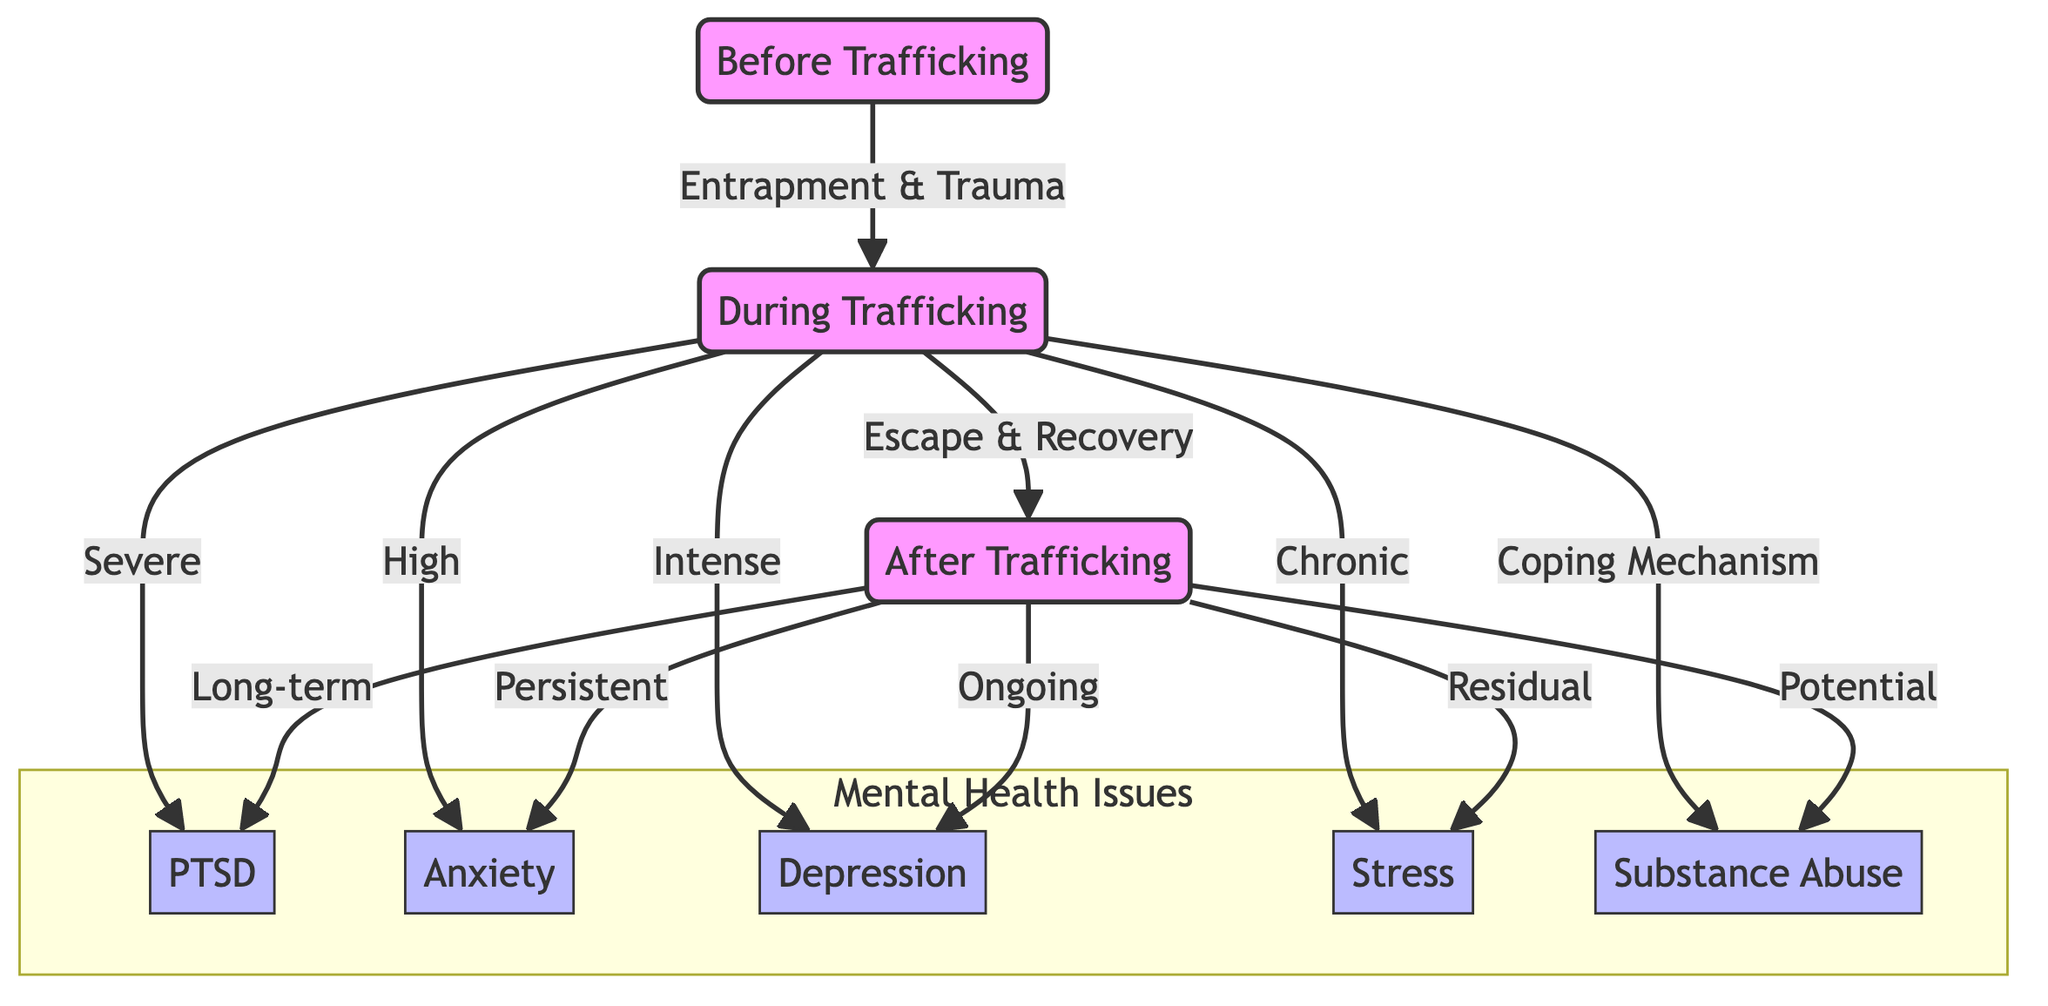What are the mental health issues identified during trafficking? The diagram highlights five mental health issues that individuals may experience during trafficking: PTSD, anxiety, depression, stress, and substance abuse. Each of these issues is connected to "During Trafficking."
Answer: PTSD, anxiety, depression, stress, substance abuse How many phases are identified in the diagram? The diagram outlines three distinct phases: Before Trafficking, During Trafficking, and After Trafficking. Each phase is represented in the diagram and marks a clear transition in the flow of mental health issues.
Answer: 3 What is the relationship between "During Trafficking" and "PTSD"? The relationship is that PTSD is linked to the "During Trafficking" phase, indicated by the arrow connecting these two nodes, where during trafficking individuals experience severe PTSD.
Answer: Severe What can be inferred about anxiety after trafficking? After trafficking, anxiety is described as "Persistent," indicating that anxiety can remain a significant issue for individuals even after escaping trafficking situations. This inference comes directly from the connection from the "After Trafficking" node to anxiety.
Answer: Persistent How many mental health issues are linked to "After Trafficking"? Four mental health issues are linked to "After Trafficking," which includes PTSD, anxiety, depression, and stress. Each of the issues is interconnected to the "After Trafficking" node.
Answer: 4 What connects "Before Trafficking" to "During Trafficking"? The connection is labeled as "Entrapment & Trauma," indicating that experiences associated with entrapment and trauma lead individuals into the "During Trafficking" phase.
Answer: Entrapment & Trauma How does substance abuse relate to the "During Trafficking" phase? Substance abuse is connected to "During Trafficking" as a coping mechanism, suggesting that individuals may use substances as a way to cope with the intense stress and trauma they experience during this phase.
Answer: Coping Mechanism What happens to PTSD after trafficking? PTSD is described as "Long-term" after trafficking, signifying that the effects of PTSD can extend well beyond the initial trafficking experience into the individual's life after their escape.
Answer: Long-term 